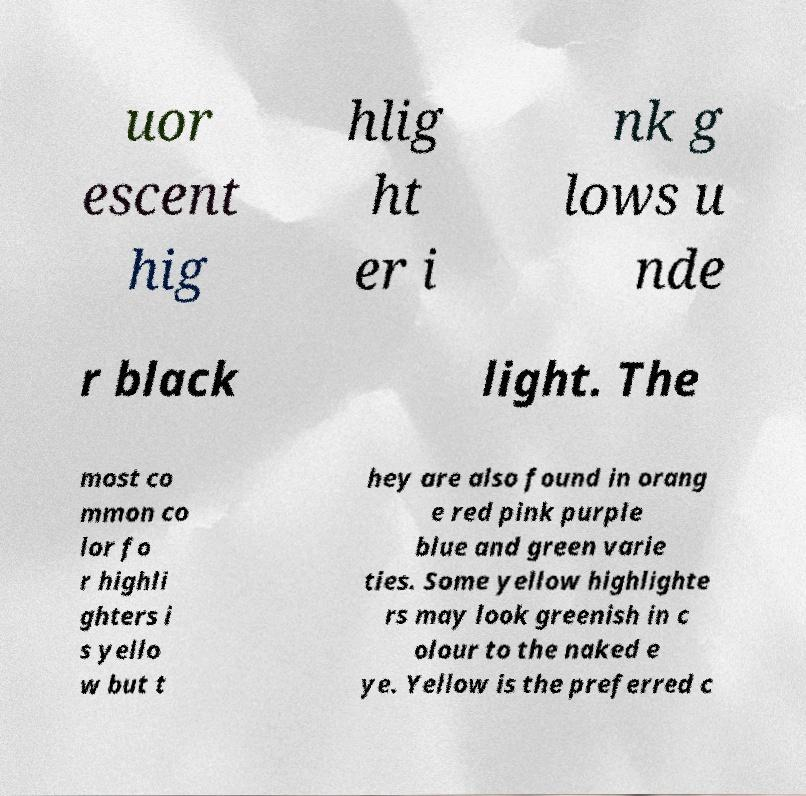There's text embedded in this image that I need extracted. Can you transcribe it verbatim? uor escent hig hlig ht er i nk g lows u nde r black light. The most co mmon co lor fo r highli ghters i s yello w but t hey are also found in orang e red pink purple blue and green varie ties. Some yellow highlighte rs may look greenish in c olour to the naked e ye. Yellow is the preferred c 